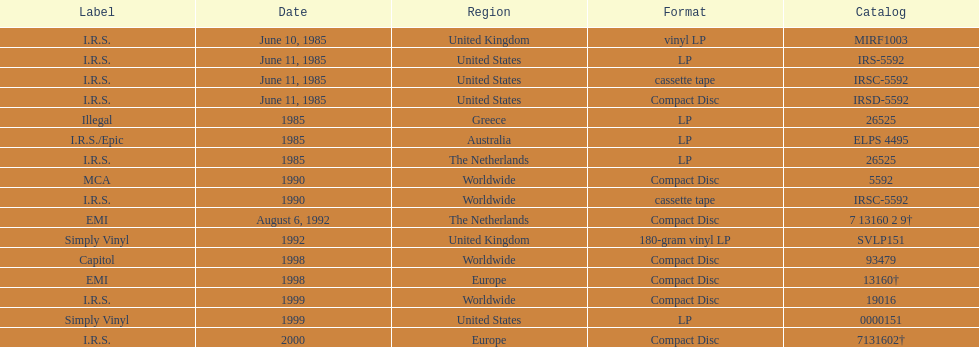Which is the only region with vinyl lp format? United Kingdom. 